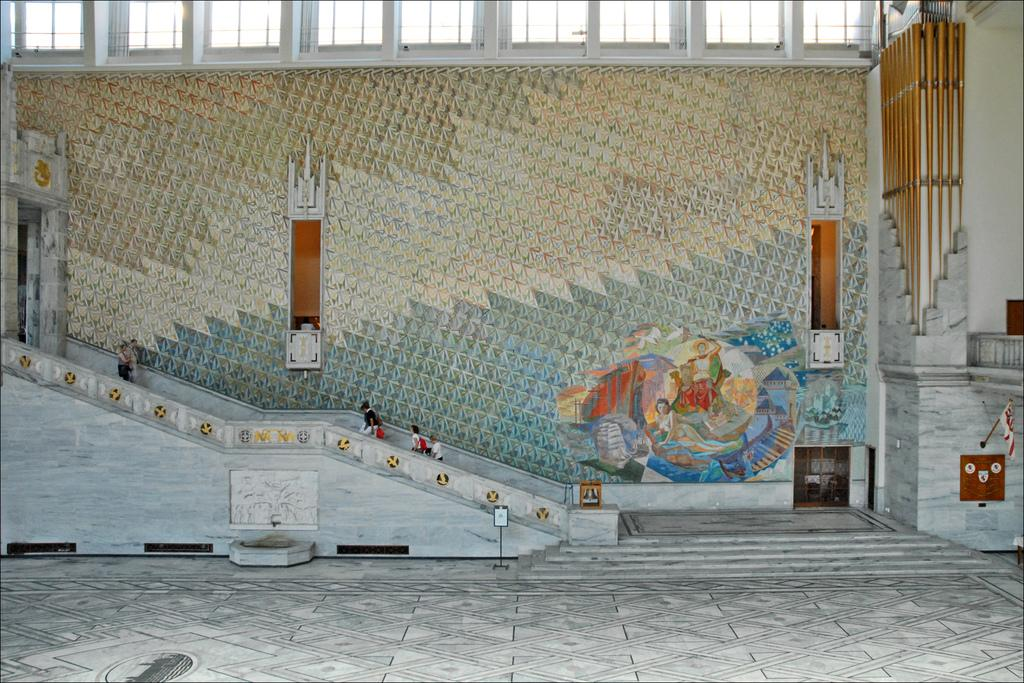What are the people in the image doing? The people in the image are walking through the stairs. What can be seen on a wall in the image? There is a painting on a wall in the image. What objects are visible at the top of the image? There are glasses visible at the top of the image. What type of kettle can be seen causing destruction in the image? There is no kettle present in the image, and therefore no destruction can be observed. What health benefits are associated with the people walking through the stairs in the image? The image does not provide information about the health benefits of walking through the stairs; it simply shows people walking. 